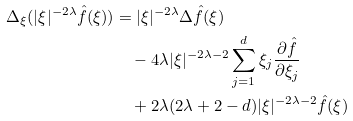Convert formula to latex. <formula><loc_0><loc_0><loc_500><loc_500>\Delta _ { \xi } ( | \xi | ^ { - 2 \lambda } \hat { f } ( \xi ) ) & = | \xi | ^ { - 2 \lambda } \Delta \hat { f } ( \xi ) \\ & \quad - 4 \lambda | \xi | ^ { - 2 \lambda - 2 } \sum _ { j = 1 } ^ { d } \xi _ { j } \frac { \partial \hat { f } } { \partial \xi _ { j } } \\ & \quad + 2 \lambda ( 2 \lambda + 2 - d ) | \xi | ^ { - 2 \lambda - 2 } \hat { f } ( \xi )</formula> 